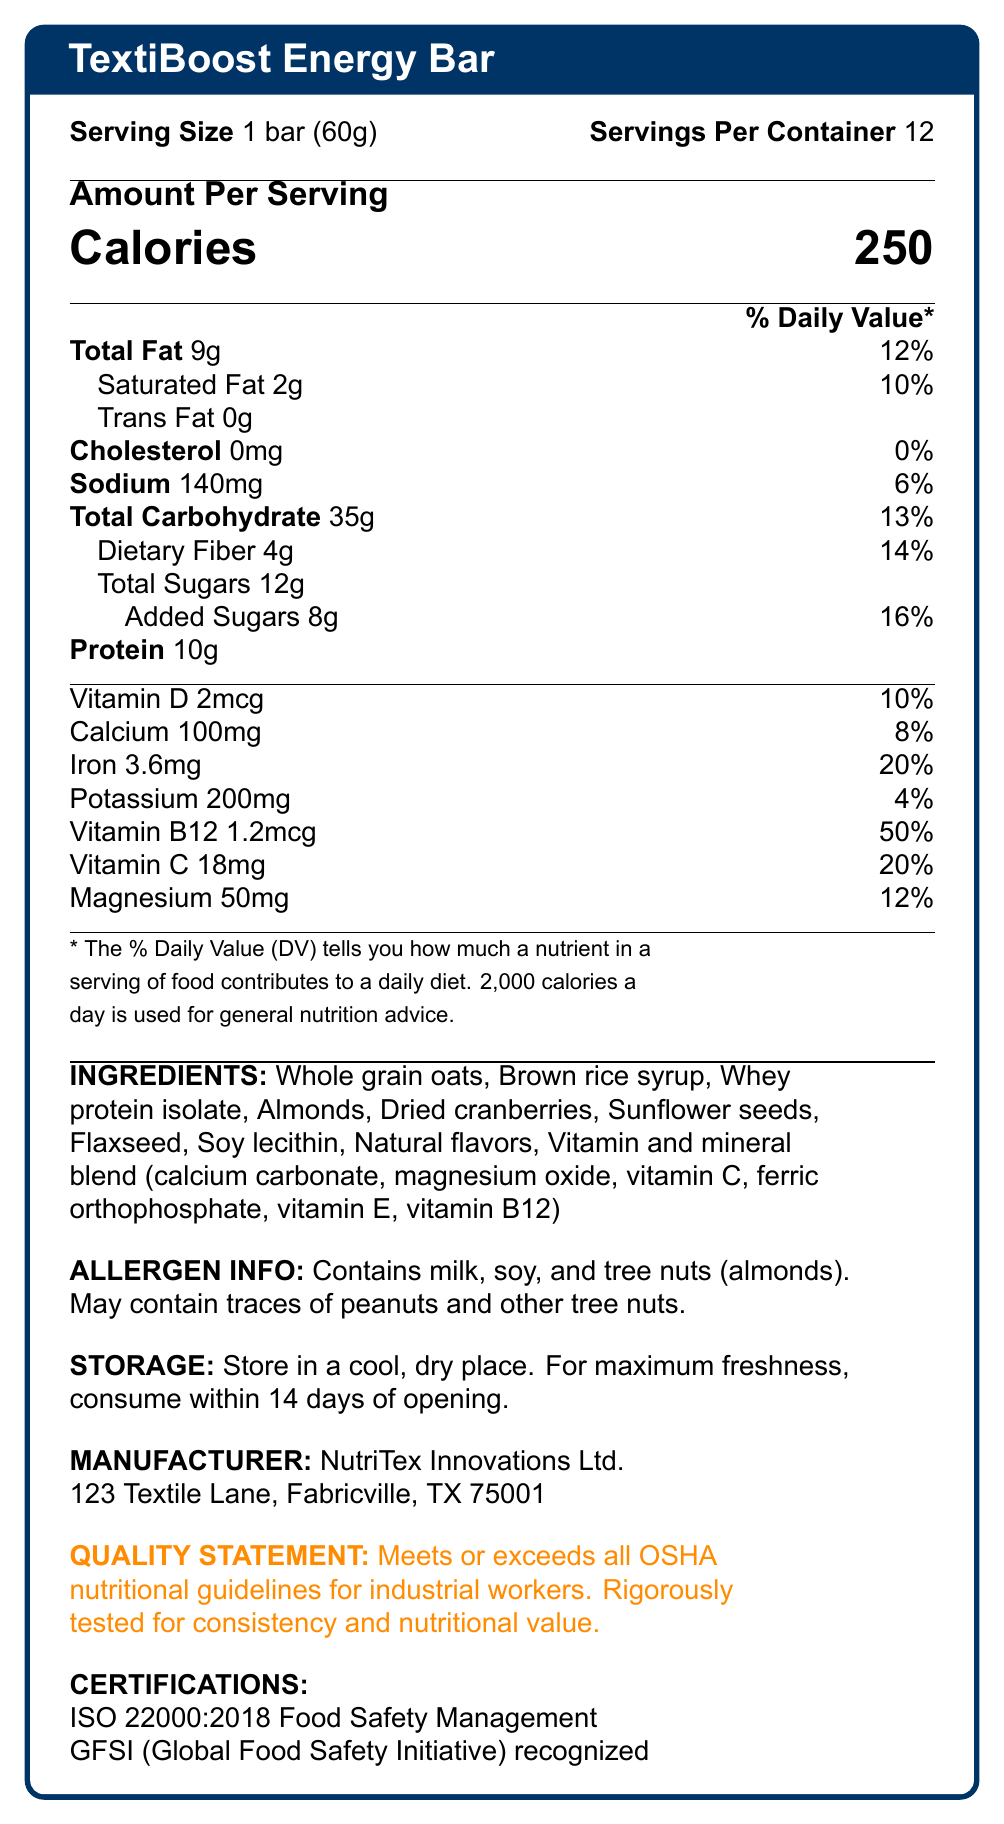What is the serving size for TextiBoost Energy Bar? The serving size is explicitly stated as "1 bar (60g)" in the document.
Answer: 1 bar (60g) How many calories are in one serving of the TextiBoost Energy Bar? The document lists the calorie count per serving as 250.
Answer: 250 What percentage of the daily value of Vitamin B12 does one energy bar provide? The Nutrition Facts Label states that one energy bar provides 50% of the daily value for Vitamin B12.
Answer: 50% Which three ingredients are listed first on the TextiBoost Energy Bar’s ingredients list? The ingredients are listed in order of predominance, with Whole grain oats, Brown rice syrup, and Whey protein isolate being the first three.
Answer: Whole grain oats, Brown rice syrup, Whey protein isolate Does the TextiBoost Energy Bar contain any added sugars? If so, how much? The label details that the energy bar contains 12g of total sugars, 8g of which are added sugars.
Answer: Yes, 8g What is the daily value percentage for iron in the TextiBoost Energy Bar? The label specifies that one bar provides 20% of the daily value for iron.
Answer: 20% What are the storage instructions for the TextiBoost Energy Bar? A. Keep refrigerated B. Store in a cool, dry place C. Store in a humid area The document states that the energy bar should be stored in a cool, dry place.
Answer: B Which certifications does the TextiBoost Energy Bar hold? A. ISO 22000:2018 B. GFSI recognized C. FDA approved D. Both A and B The label shows certifications for ISO 22000:2018 Food Safety Management and GFSI (Global Food Safety Initiative) recognition.
Answer: D Is the TextiBoost Energy Bar free from any nuts? The allergen information clearly states that the bar contains tree nuts (almonds).
Answer: No Does the TextiBoost Energy Bar meet OSHA nutritional guidelines for industrial workers? The quality statement affirms that the bar meets or exceeds all OSHA nutritional guidelines for industrial workers.
Answer: Yes Describe the main idea of this document. The document is essentially a Nutrition Facts Label that includes all necessary details to understand the nutritional content, ingredient composition, and compliance with safety and quality standards.
Answer: The document provides detailed nutritional information, ingredients, storage instructions, and certifications for the TextiBoost Energy Bar, a specially formulated energy bar designed for textile factory workers. The bar claims to meet OSHA nutritional guidelines, contains a mix of macronutrients and vitamins, and has multiple food safety certifications. How many servings per container are there? The document states that there are 12 servings per container.
Answer: 12 What amount of dietary fiber does one serving of TextiBoost Energy Bar contain? The document specifies that one serving contains 4g of dietary fiber.
Answer: 4g Can I find the manufacturing date for the TextiBoost Energy Bar in this document? The document does not provide any information about the manufacturing date.
Answer: Not enough information What is the most abundant type of fat in the TextiBoost Energy Bar? A. Saturated Fat B. Total Fat C. Trans Fat The document states that the Total Fat is 9g, which is higher compared to 2g of Saturated Fat and 0g of Trans Fat.
Answer: B 